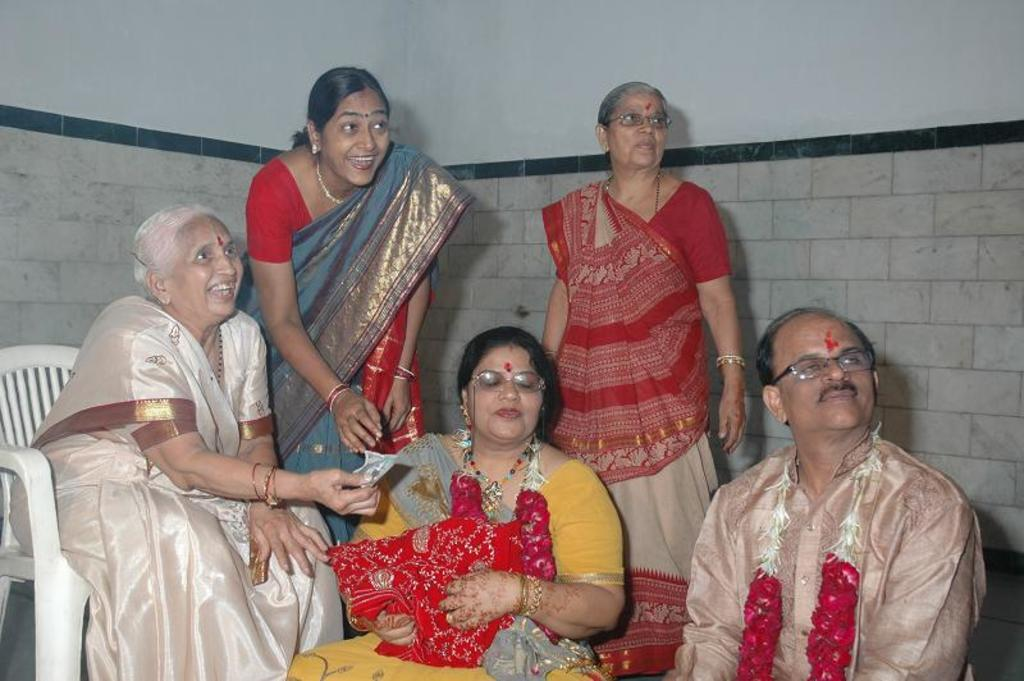How many people are sitting in the image? There are three people sitting in the image. What are the women in the image doing? There are two women standing in the image. What is one of the women holding? One woman is holding a cloth. What can be seen in the background of the image? There is a wall visible in the background of the image. How many fish are swimming around the coil in the image? There are no fish or coils present in the image. 